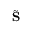Convert formula to latex. <formula><loc_0><loc_0><loc_500><loc_500>\tilde { S }</formula> 